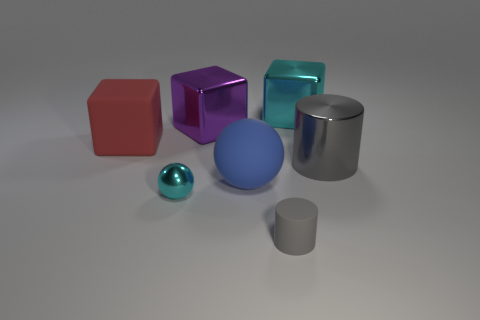Add 2 small blue rubber spheres. How many objects exist? 9 Subtract all blocks. How many objects are left? 4 Add 2 small green matte balls. How many small green matte balls exist? 2 Subtract 1 gray cylinders. How many objects are left? 6 Subtract all gray rubber objects. Subtract all big purple metal blocks. How many objects are left? 5 Add 4 cylinders. How many cylinders are left? 6 